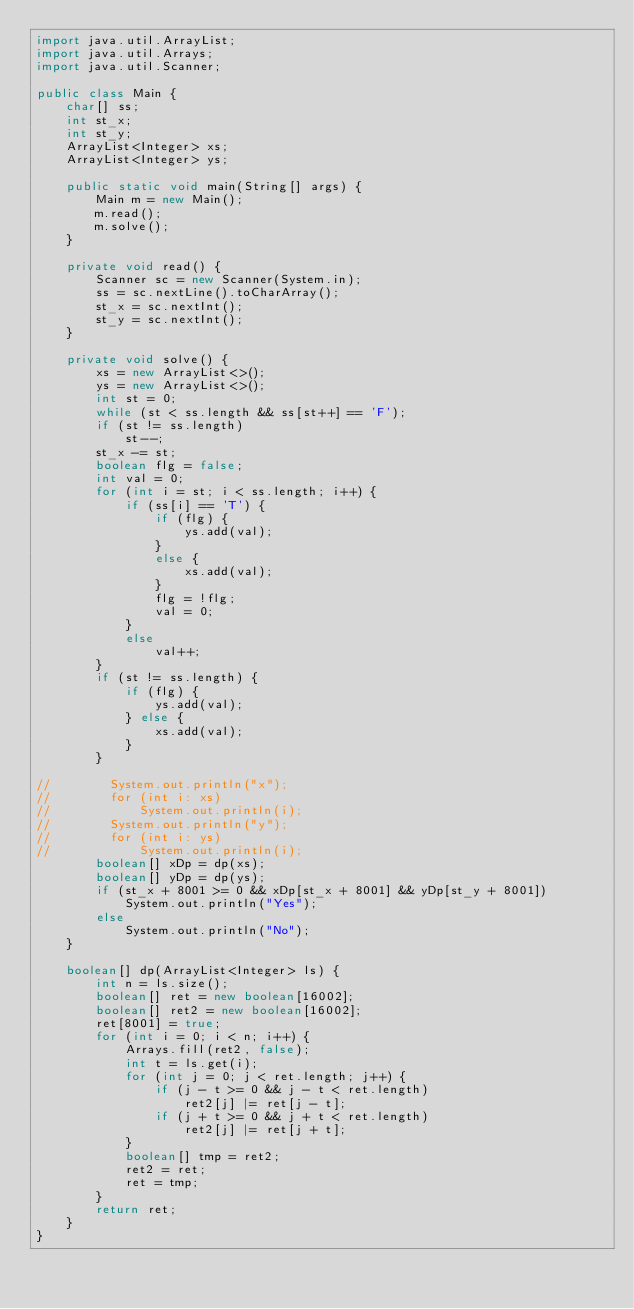Convert code to text. <code><loc_0><loc_0><loc_500><loc_500><_Java_>import java.util.ArrayList;
import java.util.Arrays;
import java.util.Scanner;

public class Main {
    char[] ss;
    int st_x;
    int st_y;
    ArrayList<Integer> xs;
    ArrayList<Integer> ys;

    public static void main(String[] args) {
        Main m = new Main();
        m.read();
        m.solve();
    }

    private void read() {
        Scanner sc = new Scanner(System.in);
        ss = sc.nextLine().toCharArray();
        st_x = sc.nextInt();
        st_y = sc.nextInt();
    }

    private void solve() {
        xs = new ArrayList<>();
        ys = new ArrayList<>();
        int st = 0;
        while (st < ss.length && ss[st++] == 'F');
        if (st != ss.length)
            st--;
        st_x -= st;
        boolean flg = false;
        int val = 0;
        for (int i = st; i < ss.length; i++) {
            if (ss[i] == 'T') {
                if (flg) {
                    ys.add(val);
                }
                else {
                    xs.add(val);
                }
                flg = !flg;
                val = 0;
            }
            else
                val++;
        }
        if (st != ss.length) {
            if (flg) {
                ys.add(val);
            } else {
                xs.add(val);
            }
        }

//        System.out.println("x");
//        for (int i: xs)
//            System.out.println(i);
//        System.out.println("y");
//        for (int i: ys)
//            System.out.println(i);
        boolean[] xDp = dp(xs);
        boolean[] yDp = dp(ys);
        if (st_x + 8001 >= 0 && xDp[st_x + 8001] && yDp[st_y + 8001])
            System.out.println("Yes");
        else
            System.out.println("No");
    }

    boolean[] dp(ArrayList<Integer> ls) {
        int n = ls.size();
        boolean[] ret = new boolean[16002];
        boolean[] ret2 = new boolean[16002];
        ret[8001] = true;
        for (int i = 0; i < n; i++) {
            Arrays.fill(ret2, false);
            int t = ls.get(i);
            for (int j = 0; j < ret.length; j++) {
                if (j - t >= 0 && j - t < ret.length)
                    ret2[j] |= ret[j - t];
                if (j + t >= 0 && j + t < ret.length)
                    ret2[j] |= ret[j + t];
            }
            boolean[] tmp = ret2;
            ret2 = ret;
            ret = tmp;
        }
        return ret;
    }
}
</code> 